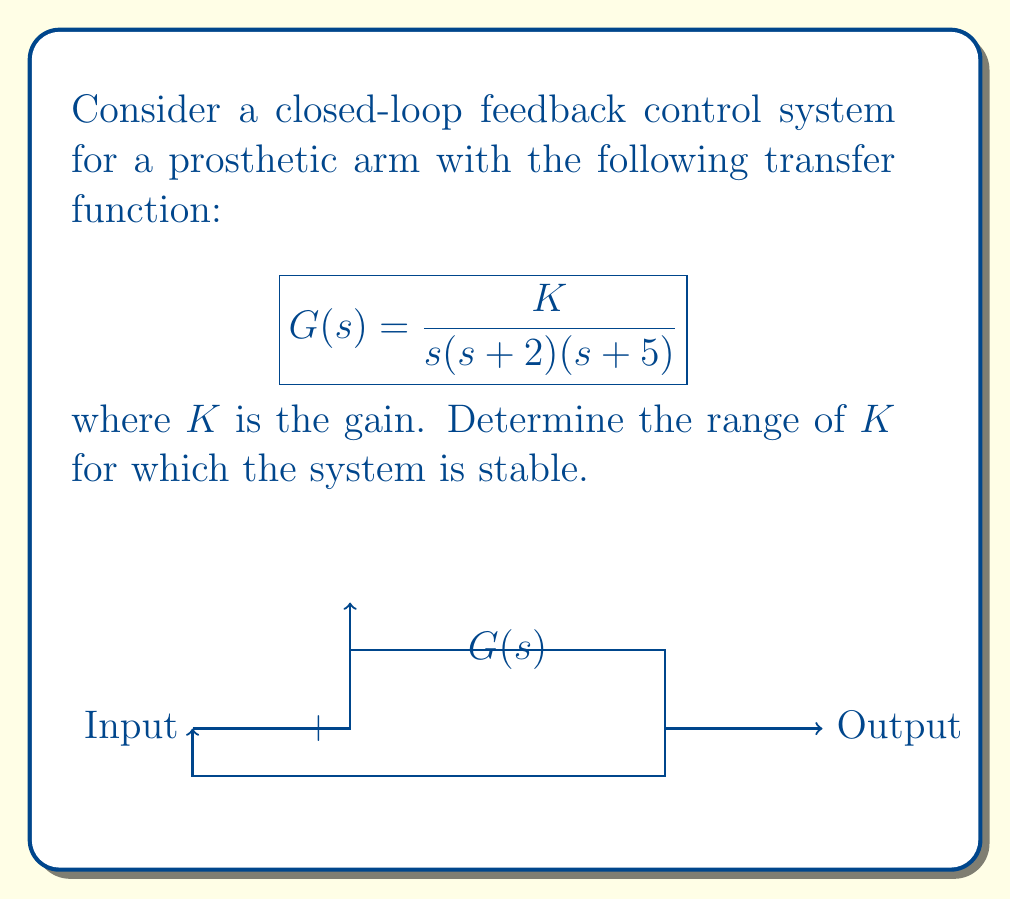Give your solution to this math problem. To determine the stability of the closed-loop system, we'll use the Routh-Hurwitz stability criterion:

1) First, we need to find the characteristic equation. For a unity feedback system, it's given by:

   $$1 + G(s) = 0$$

2) Substituting the given transfer function:

   $$1 + \frac{K}{s(s+2)(s+5)} = 0$$

3) Multiplying both sides by $s(s+2)(s+5)$:

   $$s(s+2)(s+5) + K = 0$$

4) Expanding the equation:

   $$s^3 + 7s^2 + 10s + K = 0$$

5) Now, we create the Routh array:

   $$\begin{array}{c|c}
   s^3 & 1 & 10 \\
   s^2 & 7 & K \\
   s^1 & \frac{70-K}{7} & 0 \\
   s^0 & K & 0
   \end{array}$$

6) For the system to be stable, all elements in the first column must be positive. From this, we can derive three conditions:

   a) $1 > 0$ (always true)
   b) $7 > 0$ (always true)
   c) $\frac{70-K}{7} > 0$, which implies $K < 70$
   d) $K > 0$

7) Combining conditions c and d, we get:

   $$0 < K < 70$$

This is the range of $K$ for which the system is stable.
Answer: $0 < K < 70$ 